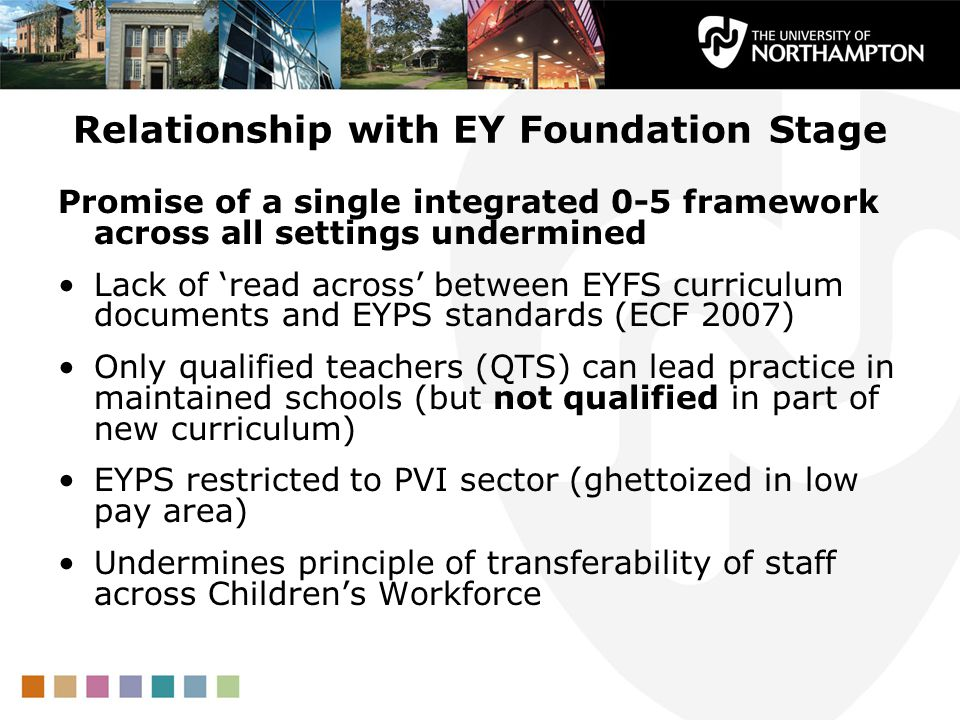Considering the image, provide a realistic scenario where the lack of 'read across' between the EYFS curriculum documents and EYPS standards impacts a school. In a realistic scenario, a school within the EYFS framework struggles to implement a cohesive educational strategy. Educators find discrepancies between the curriculum documents they use and the EYPS standards they are expected to uphold. This lack of alignment leads to confusion and inconsistency in teaching approaches. For instance, while trying to promote literacy, teachers follow different methods that aren’t harmonized, causing some children to excel while others lag behind. Moreover, planning becomes cumbersome as the staff faces difficulties in meeting both sets of expectations. Consequently, the overall quality of education suffers, and children don’t receive the uniform support they need to thrive in their early years. 